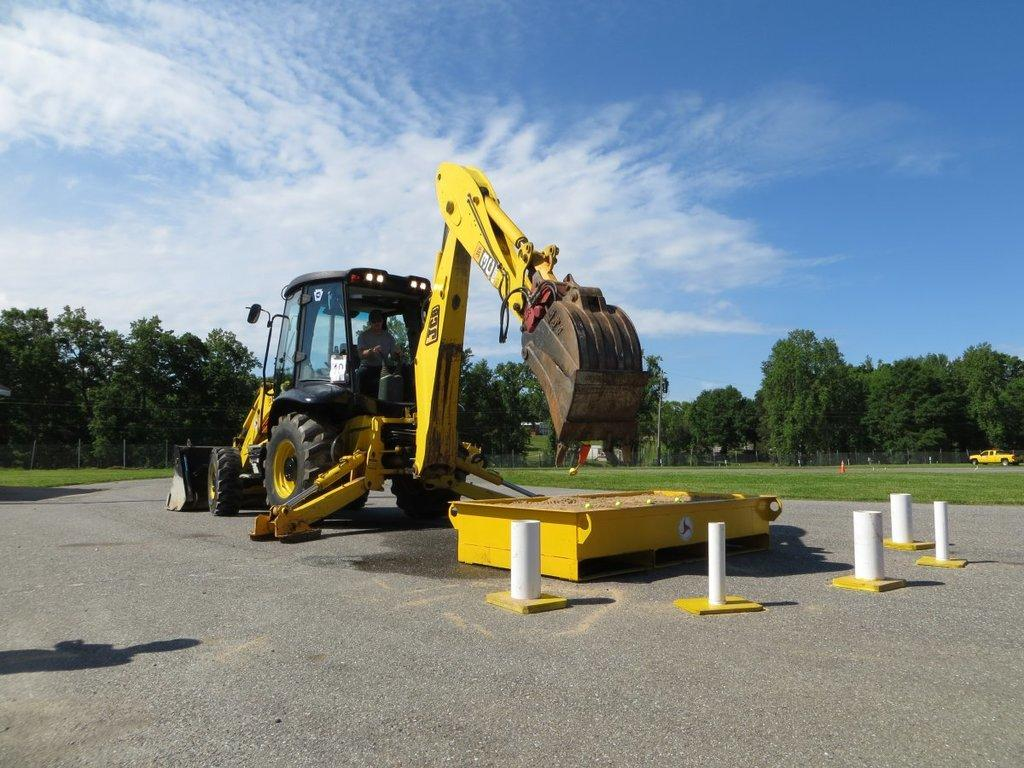What type of construction equipment is in the picture? There is a crane in the picture. What type of natural environment is visible in the picture? There are trees and grass visible in the picture. What type of vehicle is in the picture? There is a mini truck in the picture. What is on the road in the picture? There is a small metal container on the road. How would you describe the sky in the picture? The sky is blue and cloudy. How many girls are present in the picture? There are no girls present in the picture. What type of education is being provided in the picture? There is no indication of education in the picture. 